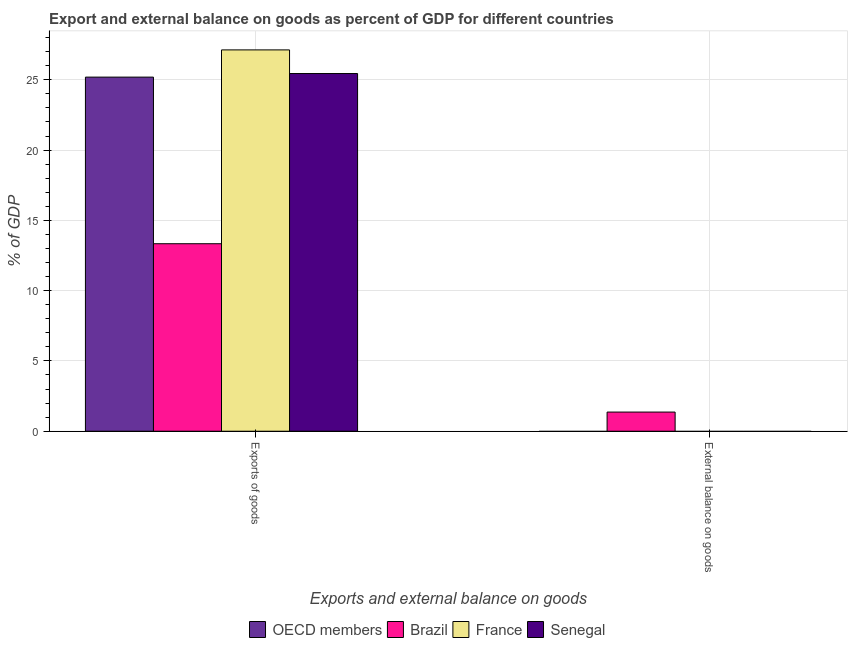Are the number of bars on each tick of the X-axis equal?
Your answer should be compact. No. How many bars are there on the 1st tick from the left?
Offer a terse response. 4. How many bars are there on the 1st tick from the right?
Your answer should be compact. 1. What is the label of the 1st group of bars from the left?
Make the answer very short. Exports of goods. What is the external balance on goods as percentage of gdp in OECD members?
Your response must be concise. 0. Across all countries, what is the maximum external balance on goods as percentage of gdp?
Make the answer very short. 1.36. Across all countries, what is the minimum export of goods as percentage of gdp?
Keep it short and to the point. 13.34. What is the total external balance on goods as percentage of gdp in the graph?
Give a very brief answer. 1.36. What is the difference between the export of goods as percentage of gdp in Brazil and that in Senegal?
Give a very brief answer. -12.11. What is the difference between the external balance on goods as percentage of gdp in OECD members and the export of goods as percentage of gdp in Senegal?
Ensure brevity in your answer.  -25.45. What is the average external balance on goods as percentage of gdp per country?
Your response must be concise. 0.34. What is the difference between the external balance on goods as percentage of gdp and export of goods as percentage of gdp in Brazil?
Your answer should be very brief. -11.98. In how many countries, is the export of goods as percentage of gdp greater than 15 %?
Ensure brevity in your answer.  3. What is the ratio of the export of goods as percentage of gdp in OECD members to that in Senegal?
Offer a terse response. 0.99. Is the export of goods as percentage of gdp in France less than that in Senegal?
Make the answer very short. No. In how many countries, is the external balance on goods as percentage of gdp greater than the average external balance on goods as percentage of gdp taken over all countries?
Offer a very short reply. 1. Does the graph contain grids?
Offer a terse response. Yes. Where does the legend appear in the graph?
Provide a short and direct response. Bottom center. What is the title of the graph?
Offer a terse response. Export and external balance on goods as percent of GDP for different countries. Does "Hungary" appear as one of the legend labels in the graph?
Your answer should be very brief. No. What is the label or title of the X-axis?
Your answer should be compact. Exports and external balance on goods. What is the label or title of the Y-axis?
Keep it short and to the point. % of GDP. What is the % of GDP of OECD members in Exports of goods?
Your answer should be very brief. 25.19. What is the % of GDP in Brazil in Exports of goods?
Give a very brief answer. 13.34. What is the % of GDP of France in Exports of goods?
Your answer should be very brief. 27.13. What is the % of GDP in Senegal in Exports of goods?
Give a very brief answer. 25.45. What is the % of GDP of OECD members in External balance on goods?
Give a very brief answer. 0. What is the % of GDP of Brazil in External balance on goods?
Provide a short and direct response. 1.36. What is the % of GDP in France in External balance on goods?
Make the answer very short. 0. What is the % of GDP of Senegal in External balance on goods?
Give a very brief answer. 0. Across all Exports and external balance on goods, what is the maximum % of GDP of OECD members?
Your answer should be compact. 25.19. Across all Exports and external balance on goods, what is the maximum % of GDP of Brazil?
Provide a succinct answer. 13.34. Across all Exports and external balance on goods, what is the maximum % of GDP in France?
Provide a short and direct response. 27.13. Across all Exports and external balance on goods, what is the maximum % of GDP of Senegal?
Keep it short and to the point. 25.45. Across all Exports and external balance on goods, what is the minimum % of GDP of Brazil?
Your answer should be very brief. 1.36. What is the total % of GDP in OECD members in the graph?
Give a very brief answer. 25.19. What is the total % of GDP in Brazil in the graph?
Offer a very short reply. 14.7. What is the total % of GDP in France in the graph?
Offer a terse response. 27.13. What is the total % of GDP of Senegal in the graph?
Provide a short and direct response. 25.45. What is the difference between the % of GDP in Brazil in Exports of goods and that in External balance on goods?
Your answer should be compact. 11.98. What is the difference between the % of GDP in OECD members in Exports of goods and the % of GDP in Brazil in External balance on goods?
Provide a short and direct response. 23.83. What is the average % of GDP in OECD members per Exports and external balance on goods?
Ensure brevity in your answer.  12.6. What is the average % of GDP of Brazil per Exports and external balance on goods?
Give a very brief answer. 7.35. What is the average % of GDP in France per Exports and external balance on goods?
Make the answer very short. 13.56. What is the average % of GDP of Senegal per Exports and external balance on goods?
Offer a very short reply. 12.72. What is the difference between the % of GDP of OECD members and % of GDP of Brazil in Exports of goods?
Keep it short and to the point. 11.85. What is the difference between the % of GDP in OECD members and % of GDP in France in Exports of goods?
Your response must be concise. -1.94. What is the difference between the % of GDP in OECD members and % of GDP in Senegal in Exports of goods?
Make the answer very short. -0.25. What is the difference between the % of GDP in Brazil and % of GDP in France in Exports of goods?
Provide a succinct answer. -13.79. What is the difference between the % of GDP of Brazil and % of GDP of Senegal in Exports of goods?
Give a very brief answer. -12.11. What is the difference between the % of GDP of France and % of GDP of Senegal in Exports of goods?
Ensure brevity in your answer.  1.68. What is the ratio of the % of GDP in Brazil in Exports of goods to that in External balance on goods?
Your answer should be very brief. 9.79. What is the difference between the highest and the second highest % of GDP in Brazil?
Make the answer very short. 11.98. What is the difference between the highest and the lowest % of GDP in OECD members?
Make the answer very short. 25.19. What is the difference between the highest and the lowest % of GDP in Brazil?
Provide a succinct answer. 11.98. What is the difference between the highest and the lowest % of GDP in France?
Provide a succinct answer. 27.13. What is the difference between the highest and the lowest % of GDP in Senegal?
Provide a short and direct response. 25.45. 